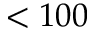<formula> <loc_0><loc_0><loc_500><loc_500>< 1 0 0</formula> 